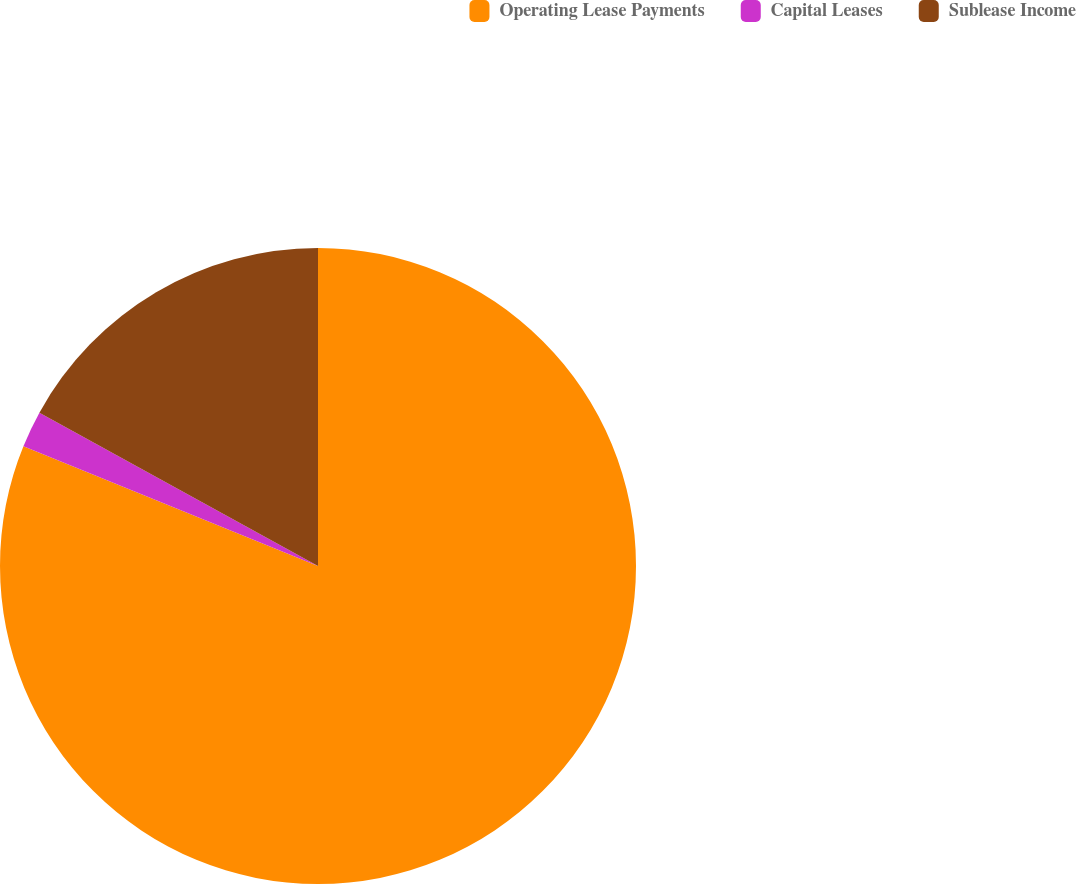Convert chart to OTSL. <chart><loc_0><loc_0><loc_500><loc_500><pie_chart><fcel>Operating Lease Payments<fcel>Capital Leases<fcel>Sublease Income<nl><fcel>81.14%<fcel>1.86%<fcel>16.99%<nl></chart> 